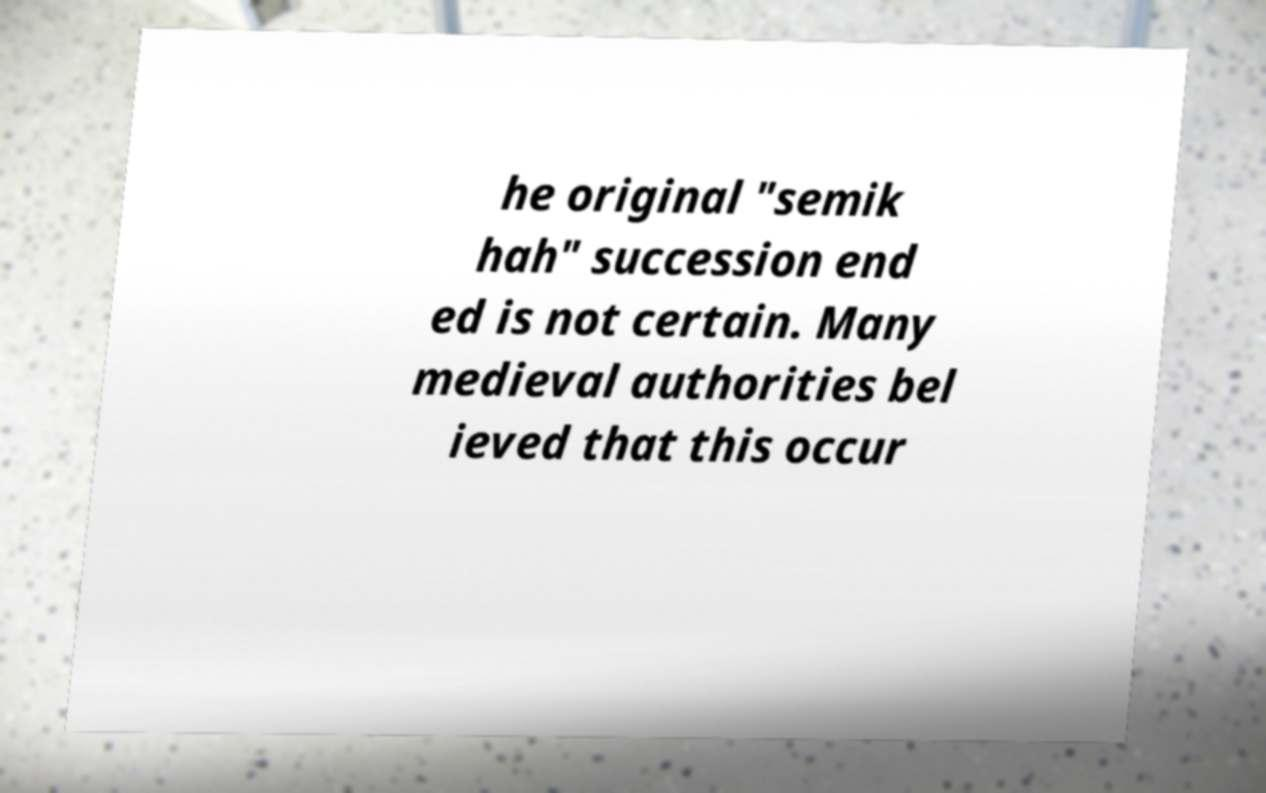Please read and relay the text visible in this image. What does it say? he original "semik hah" succession end ed is not certain. Many medieval authorities bel ieved that this occur 